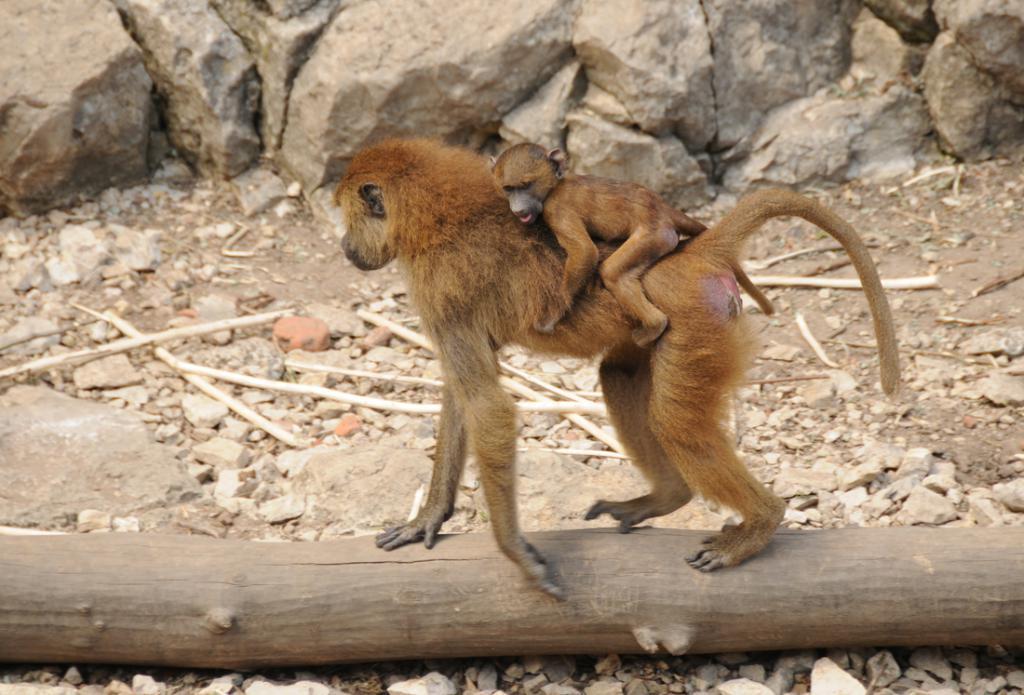Can you describe this image briefly? In this image there is a monkey holding its baby standing on the wood, there are few stones and sticks. 